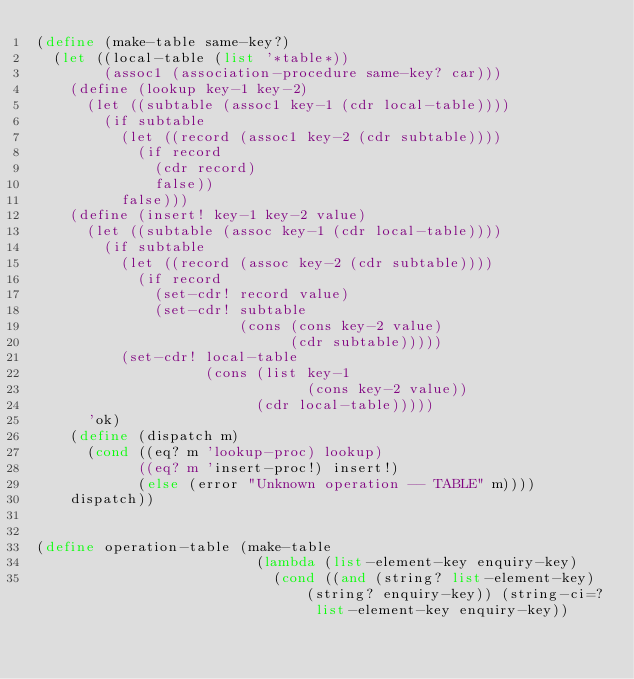Convert code to text. <code><loc_0><loc_0><loc_500><loc_500><_Scheme_>(define (make-table same-key?)
  (let ((local-table (list '*table*))
        (assoc1 (association-procedure same-key? car)))
    (define (lookup key-1 key-2)
      (let ((subtable (assoc1 key-1 (cdr local-table))))
        (if subtable
          (let ((record (assoc1 key-2 (cdr subtable))))
            (if record
              (cdr record)
              false))
          false)))
    (define (insert! key-1 key-2 value)
      (let ((subtable (assoc key-1 (cdr local-table))))
        (if subtable
          (let ((record (assoc key-2 (cdr subtable))))
            (if record
              (set-cdr! record value)
              (set-cdr! subtable
                        (cons (cons key-2 value)
                              (cdr subtable)))))
          (set-cdr! local-table
                    (cons (list key-1
                                (cons key-2 value))
                          (cdr local-table)))))
      'ok)    
    (define (dispatch m)
      (cond ((eq? m 'lookup-proc) lookup)
            ((eq? m 'insert-proc!) insert!)
            (else (error "Unknown operation -- TABLE" m))))
    dispatch))


(define operation-table (make-table 
                          (lambda (list-element-key enquiry-key)
                            (cond ((and (string? list-element-key) (string? enquiry-key)) (string-ci=? list-element-key enquiry-key))</code> 